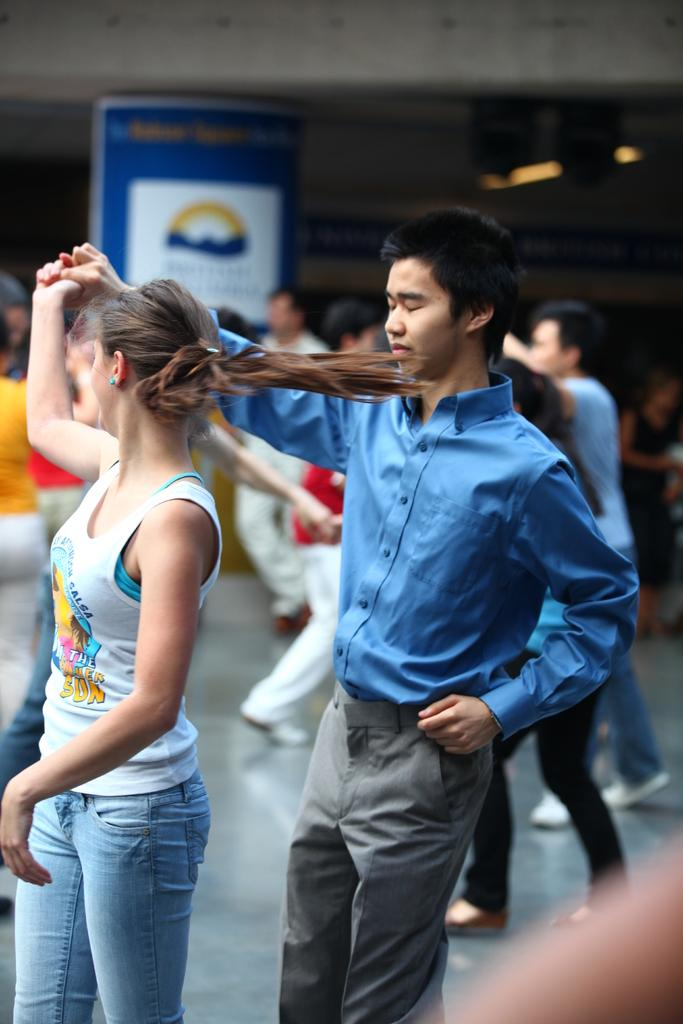What are the people in the image doing? The people in the image are dancing. Where are the people dancing? The people are dancing on the floor. What can be seen in the background of the image? There is a banner, the ceiling, and lights visible in the background of the image. What type of request can be seen written on the nose of one of the dancers in the image? There is no nose or request visible on any of the dancers in the image. 